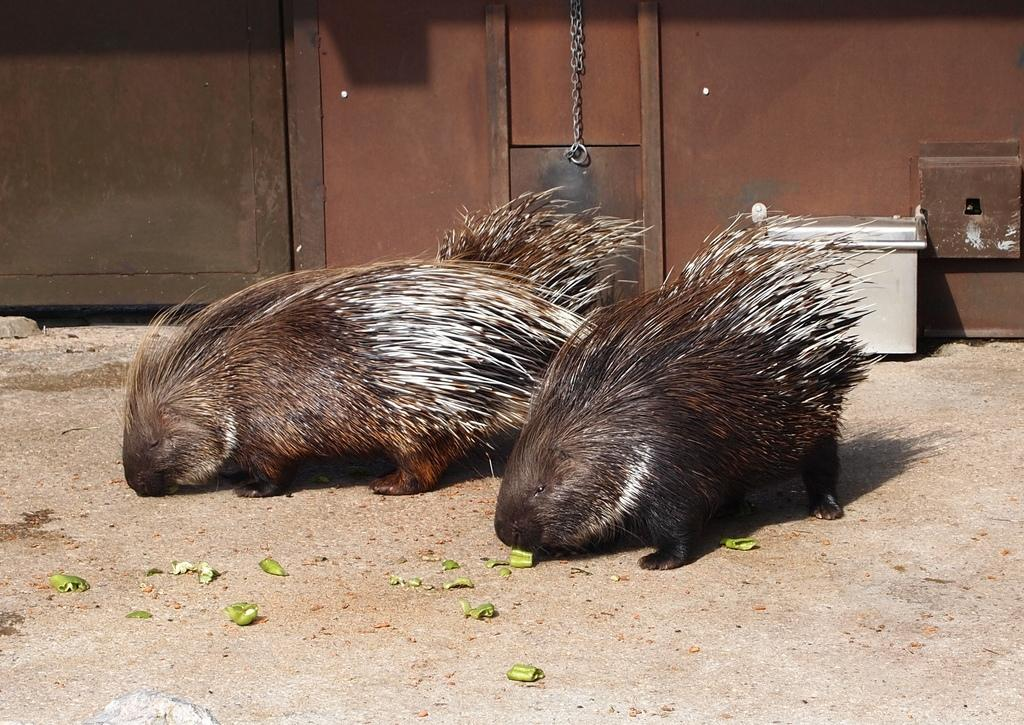What animals are on the ground in the image? There are porcupines on the ground in the image. What objects can be seen on the right side of the image? There are metal boxes on the right side of the image. What type of structure is visible in the background of the image? There appears to be a metal wall in the background of the image. What type of honey is being collected by the porcupines in the image? There is no honey present in the image, and the porcupines are not collecting anything. Can you see any wounds or signs of pain on the porcupines in the image? There is no indication of wounds or pain on the porcupines in the image; they appear to be resting on the ground. 